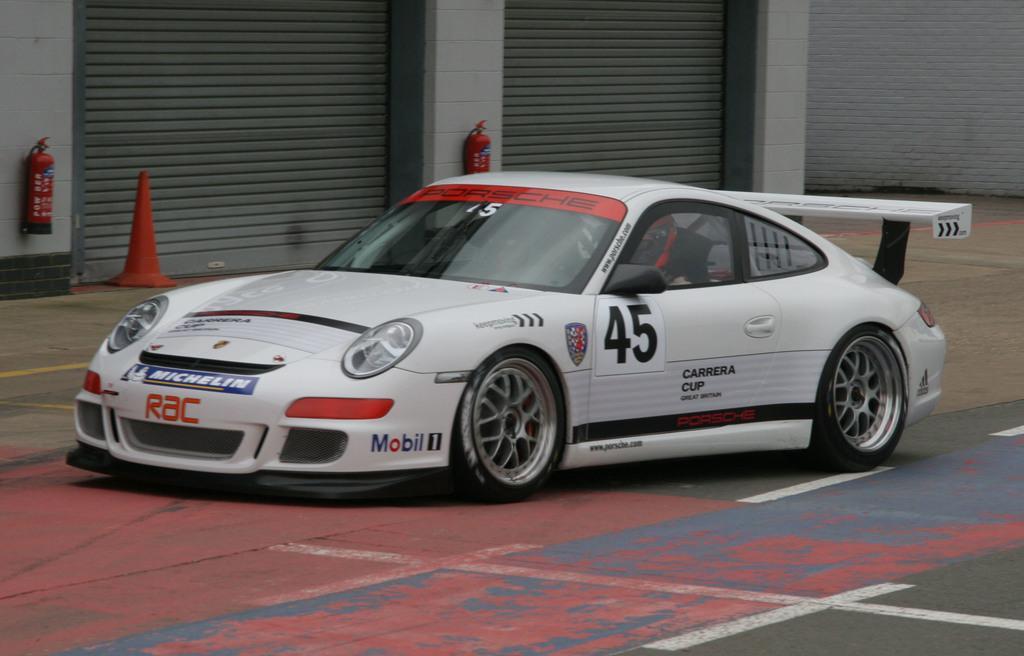Could you give a brief overview of what you see in this image? This image is taken outdoors. At the bottom of the image there is a road. In the background there is a wall with two shutters and there are two fire extinguishers. In the middle of the image a car is moving on the road. 